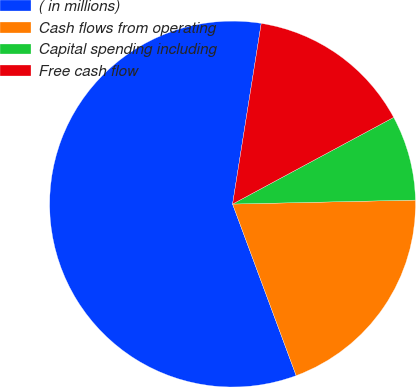<chart> <loc_0><loc_0><loc_500><loc_500><pie_chart><fcel>( in millions)<fcel>Cash flows from operating<fcel>Capital spending including<fcel>Free cash flow<nl><fcel>58.16%<fcel>19.7%<fcel>7.51%<fcel>14.64%<nl></chart> 